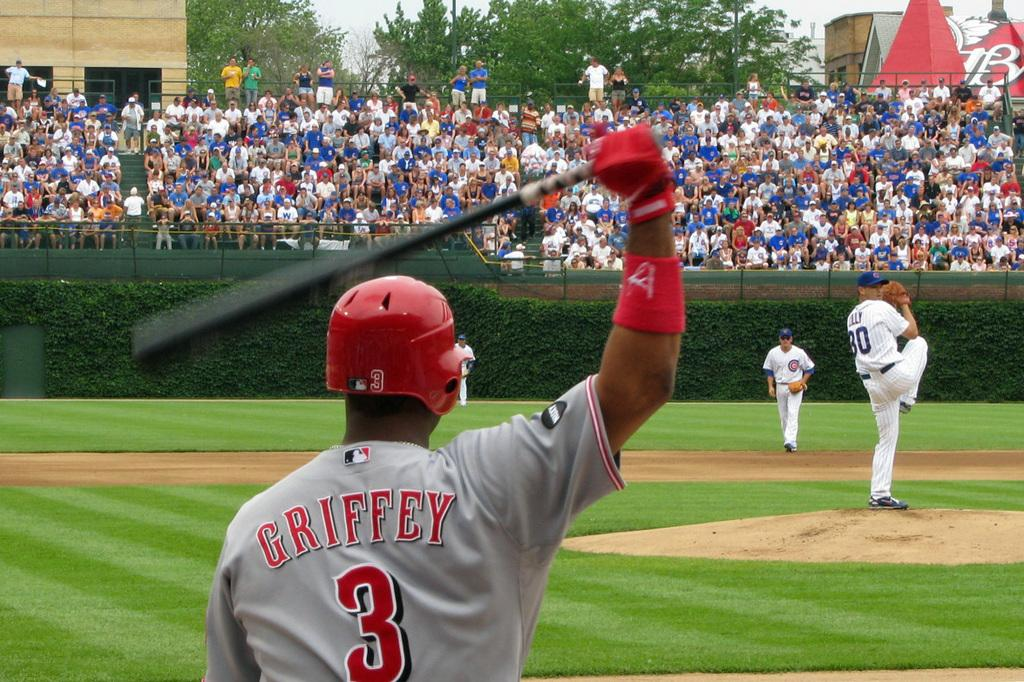Provide a one-sentence caption for the provided image. The pitcher is posed to pitch the ball to player number 3. 